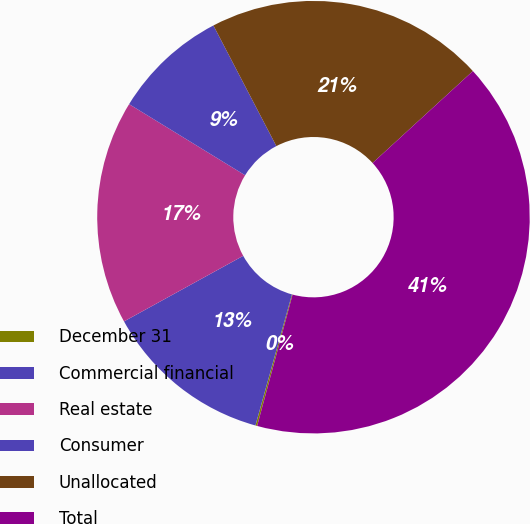<chart> <loc_0><loc_0><loc_500><loc_500><pie_chart><fcel>December 31<fcel>Commercial financial<fcel>Real estate<fcel>Consumer<fcel>Unallocated<fcel>Total<nl><fcel>0.13%<fcel>12.67%<fcel>16.76%<fcel>8.59%<fcel>20.85%<fcel>41.0%<nl></chart> 